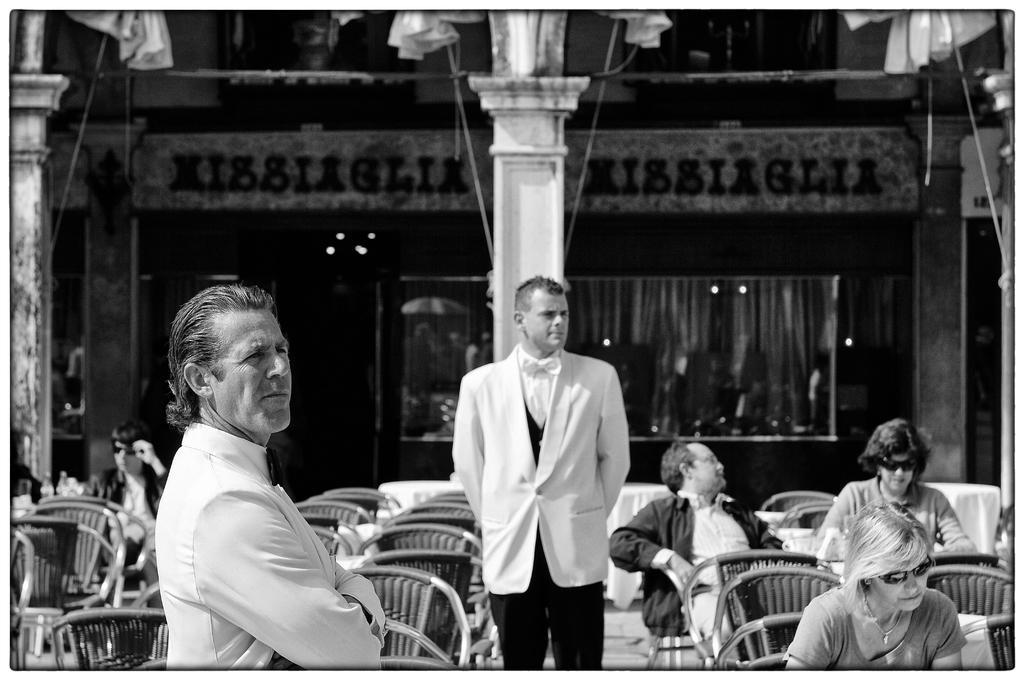How would you summarize this image in a sentence or two? In the middle a man is standing he wear a white coat there are people who are sitting on the chairs that there is a glass wall and building. 